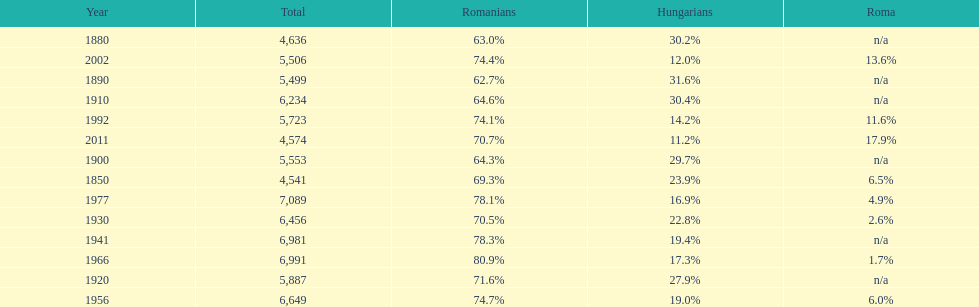According to the final year on this chart, what was the percentage of romanians in the population? 70.7%. 